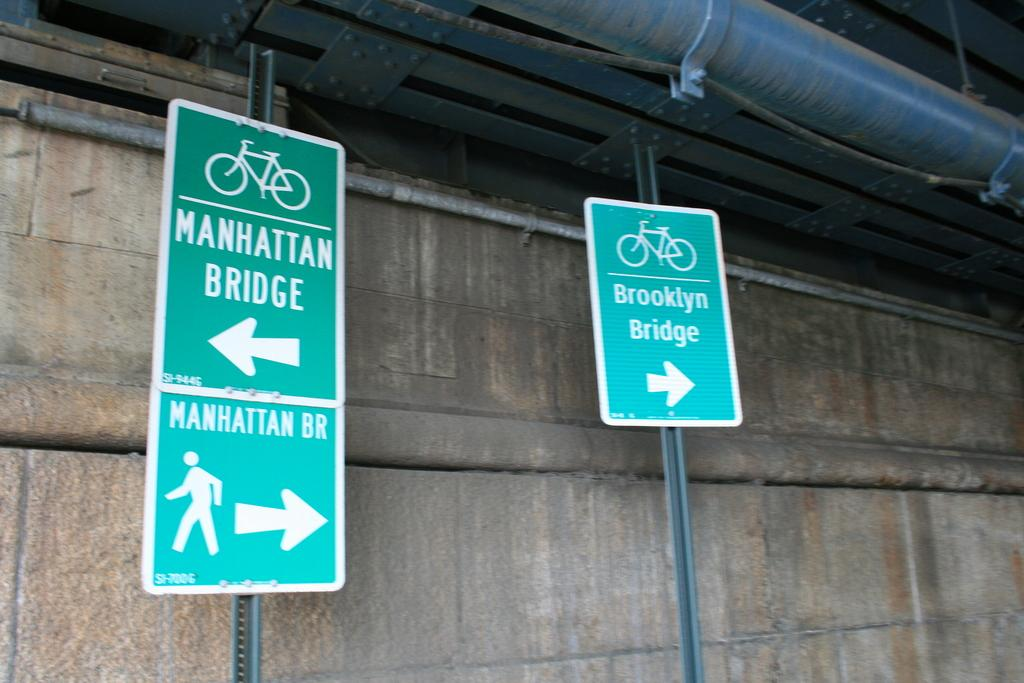<image>
Write a terse but informative summary of the picture. Signs showing that the Manhattan Bridge is to the left and the Brooklyn Bridge is to the right. 